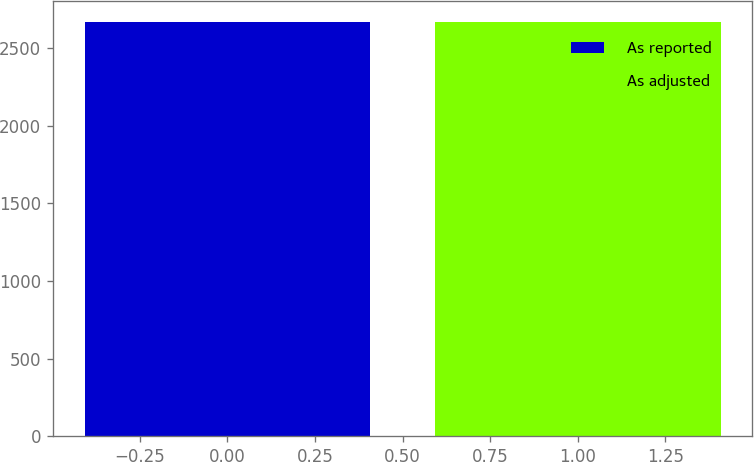<chart> <loc_0><loc_0><loc_500><loc_500><bar_chart><fcel>As reported<fcel>As adjusted<nl><fcel>2667<fcel>2667.1<nl></chart> 